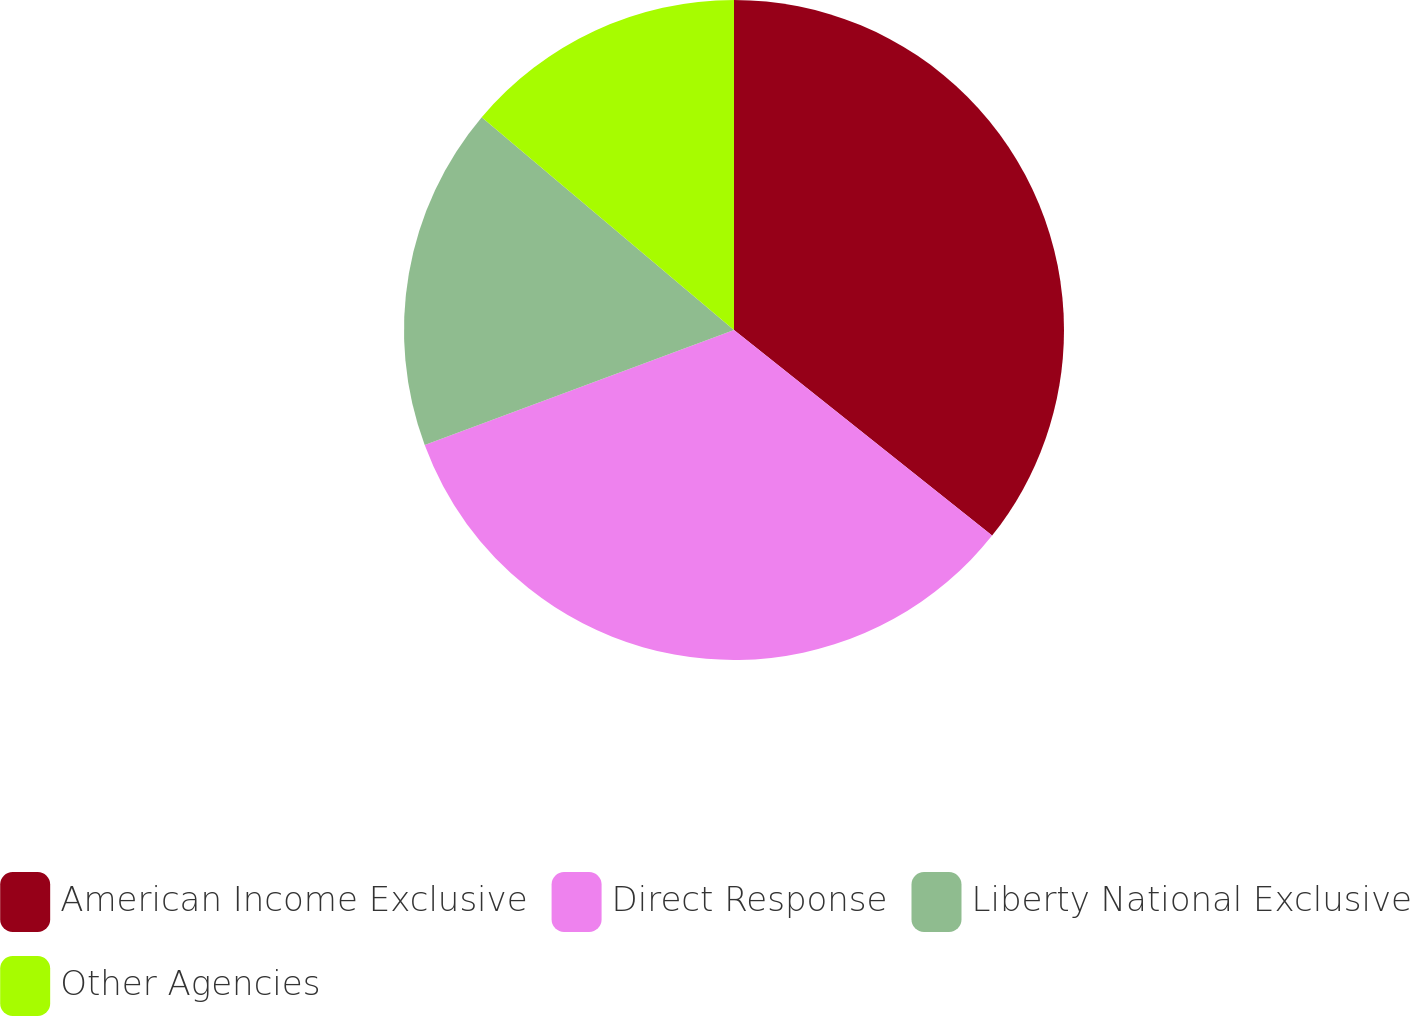Convert chart. <chart><loc_0><loc_0><loc_500><loc_500><pie_chart><fcel>American Income Exclusive<fcel>Direct Response<fcel>Liberty National Exclusive<fcel>Other Agencies<nl><fcel>35.71%<fcel>33.63%<fcel>16.82%<fcel>13.85%<nl></chart> 